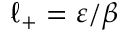<formula> <loc_0><loc_0><loc_500><loc_500>\ell _ { + } = \varepsilon / \beta</formula> 